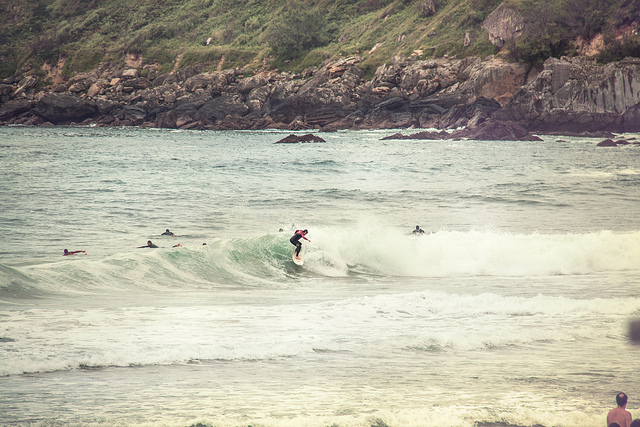<image>What kind of animal is standing on the hillside? It is ambiguous what kind of animal is standing on the hillside. It could be a dog, sheep, bird, cows, horse or human. What kind of animal is standing on the hillside? It is unknown what kind of animal is standing on the hillside. It can be seen as a dog, sheep, bird, cows, horse, human or even none. 